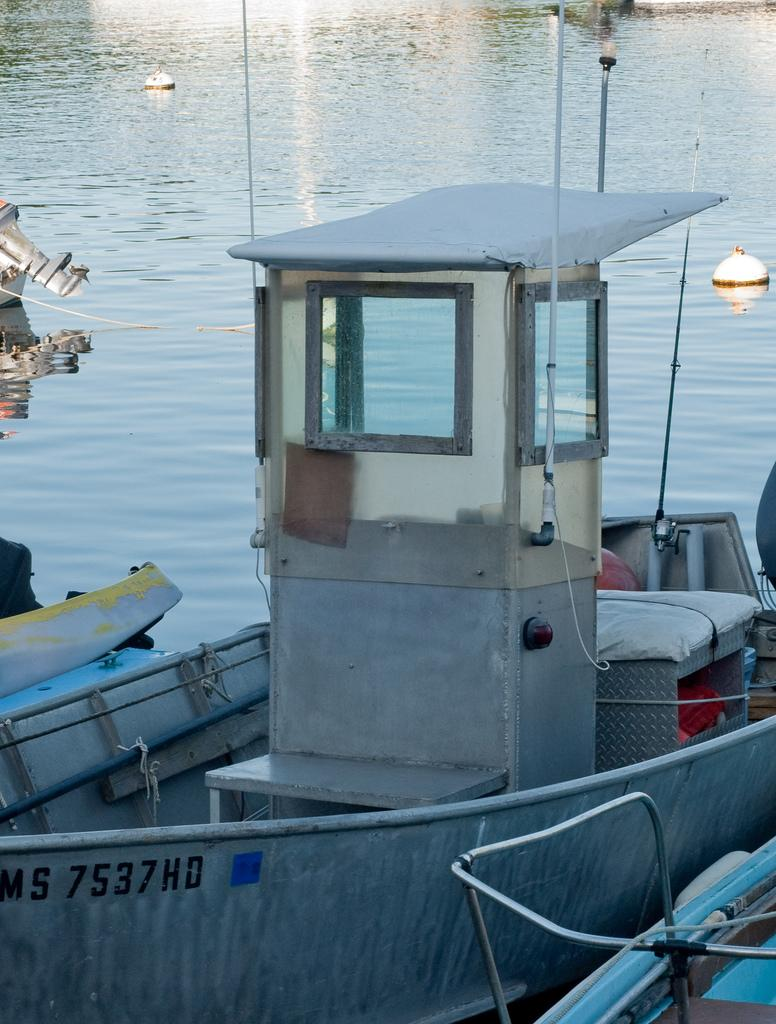What is the main subject of the image? The main subject of the image is a boat. What is the boat doing in the image? The boat is sailing on the water. What type of wax can be seen melting on the boat's wing in the image? There is no wax or wing present on the boat in the image. 